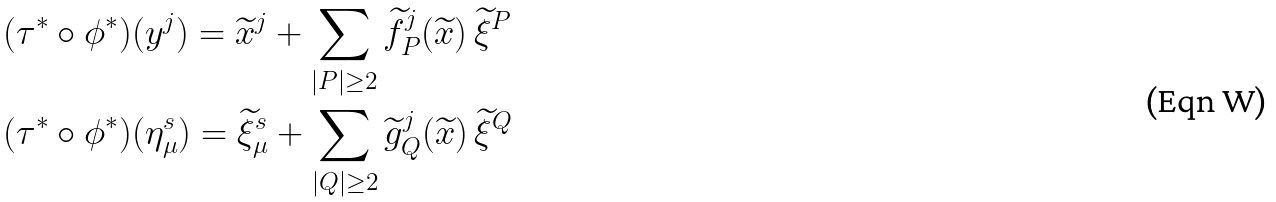<formula> <loc_0><loc_0><loc_500><loc_500>& ( \tau ^ { * } \circ \phi ^ { * } ) ( y ^ { j } ) = \widetilde { x } ^ { j } + \sum _ { | P | \geq 2 } \widetilde { f } ^ { j } _ { P } ( \widetilde { x } ) \, \widetilde { \xi } ^ { P } \\ & ( \tau ^ { * } \circ \phi ^ { * } ) ( \eta ^ { s } _ { \mu } ) = \widetilde { \xi } ^ { s } _ { \mu } + \sum _ { | Q | \geq 2 } \widetilde { g } ^ { j } _ { Q } ( \widetilde { x } ) \, \widetilde { \xi } ^ { Q }</formula> 